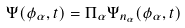Convert formula to latex. <formula><loc_0><loc_0><loc_500><loc_500>\Psi ( \phi _ { \alpha } , t ) = \Pi _ { \alpha } \Psi _ { n _ { \alpha } } ( \phi _ { \alpha } , t )</formula> 